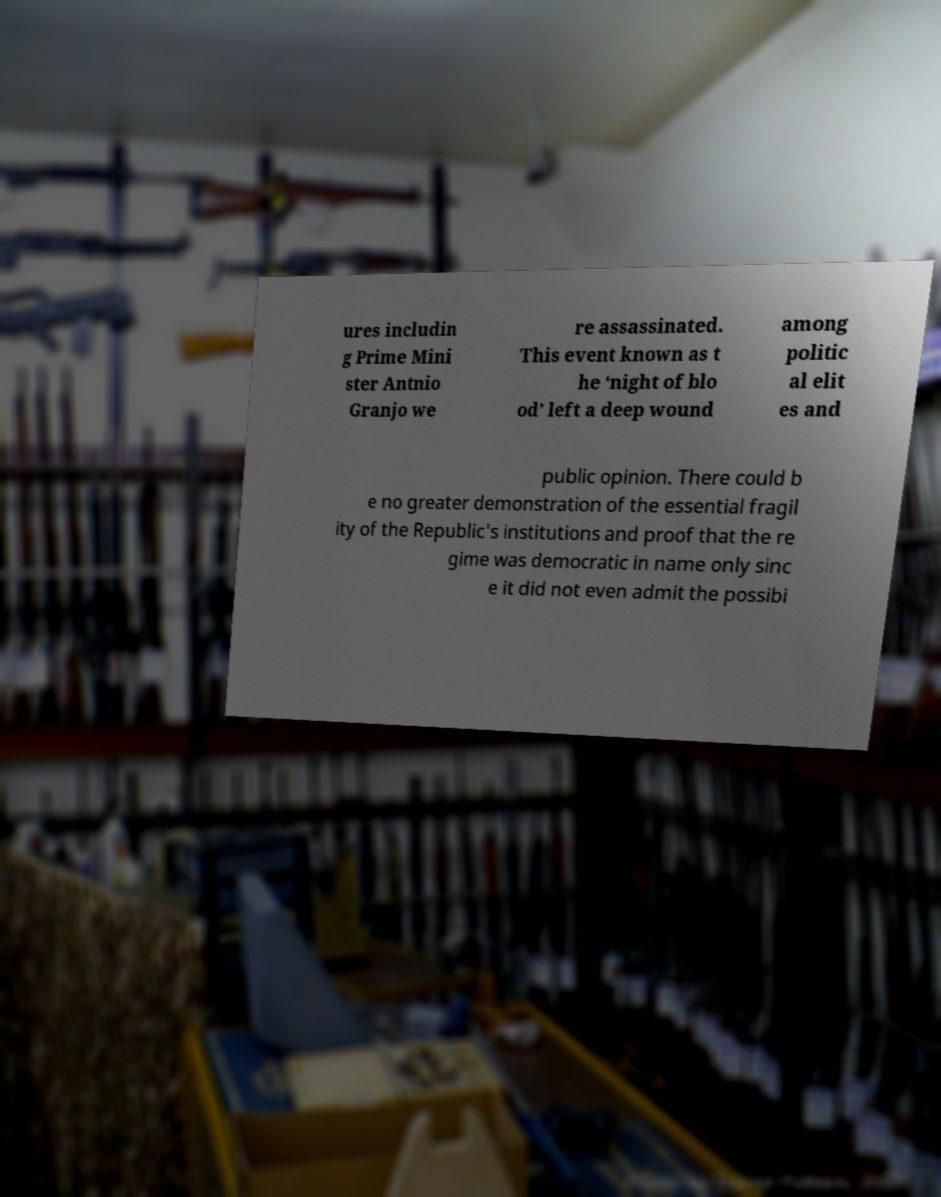There's text embedded in this image that I need extracted. Can you transcribe it verbatim? ures includin g Prime Mini ster Antnio Granjo we re assassinated. This event known as t he ‘night of blo od’ left a deep wound among politic al elit es and public opinion. There could b e no greater demonstration of the essential fragil ity of the Republic's institutions and proof that the re gime was democratic in name only sinc e it did not even admit the possibi 